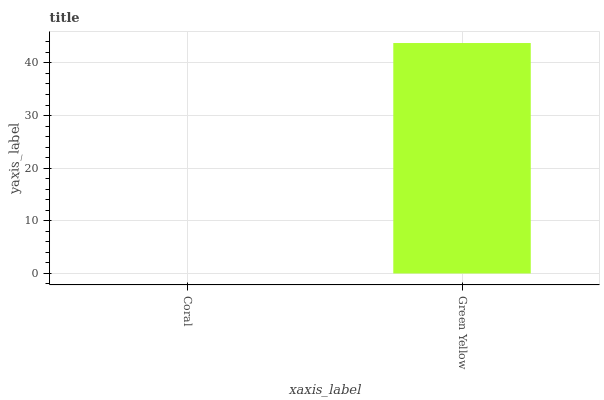Is Coral the minimum?
Answer yes or no. Yes. Is Green Yellow the maximum?
Answer yes or no. Yes. Is Green Yellow the minimum?
Answer yes or no. No. Is Green Yellow greater than Coral?
Answer yes or no. Yes. Is Coral less than Green Yellow?
Answer yes or no. Yes. Is Coral greater than Green Yellow?
Answer yes or no. No. Is Green Yellow less than Coral?
Answer yes or no. No. Is Green Yellow the high median?
Answer yes or no. Yes. Is Coral the low median?
Answer yes or no. Yes. Is Coral the high median?
Answer yes or no. No. Is Green Yellow the low median?
Answer yes or no. No. 